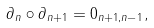<formula> <loc_0><loc_0><loc_500><loc_500>\partial _ { n } \circ \partial _ { n + 1 } = 0 _ { n + 1 , n - 1 } ,</formula> 